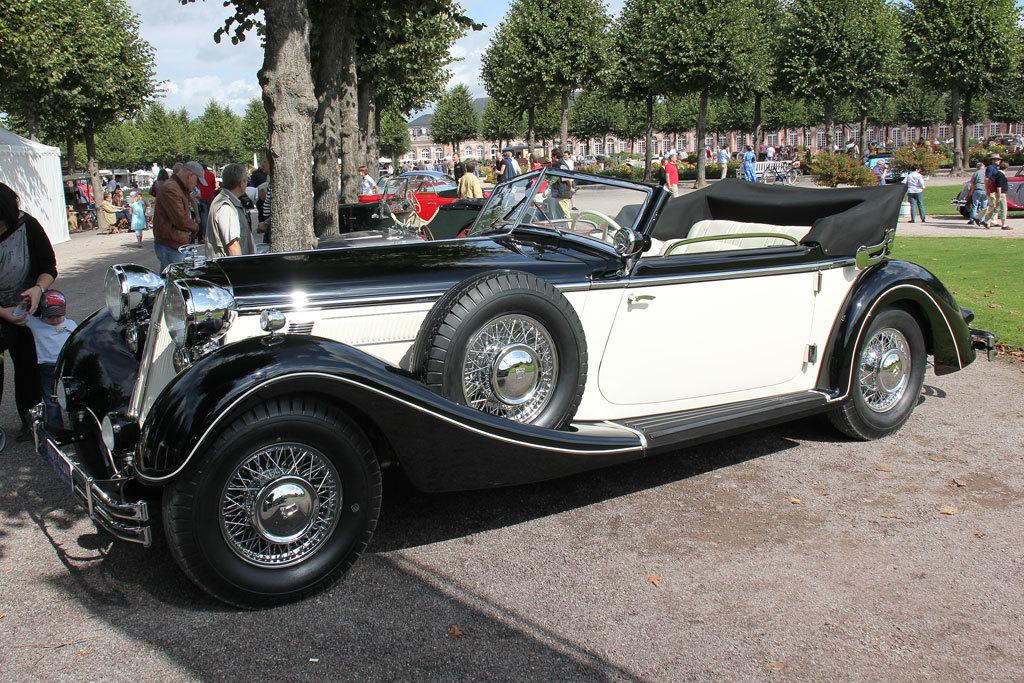What types of objects are on the ground in the image? There are vehicles on the ground in the image. Who or what else can be seen in the image? There are people in the image. What type of vegetation is present in the image? There are trees in the image. What is the ground covered with in the image? There is grass visible in the image. What can be seen in the background of the image? The sky is visible in the background of the image. What color is the chin of the person in the image? There is no chin visible in the image, as the faces of the people are not shown. Who is the friend of the person in the image? There is no friend present in the image, as the conversation focuses on the objects and subjects visible in the image. 